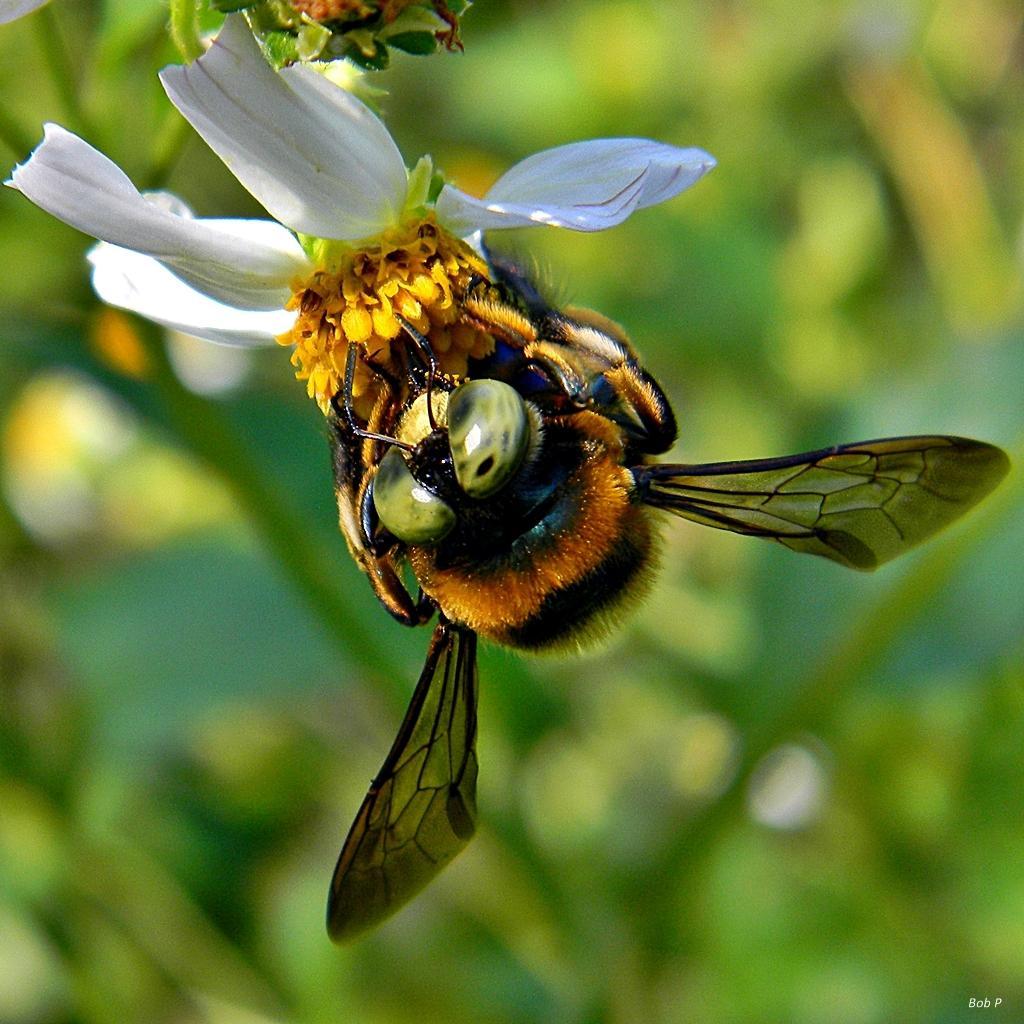Can you describe this image briefly? In this image I see a flower which is of white and yellow in color and I see an insect over here and I see the watermark over here and I see that it is blurred in the background and it is totally green. 